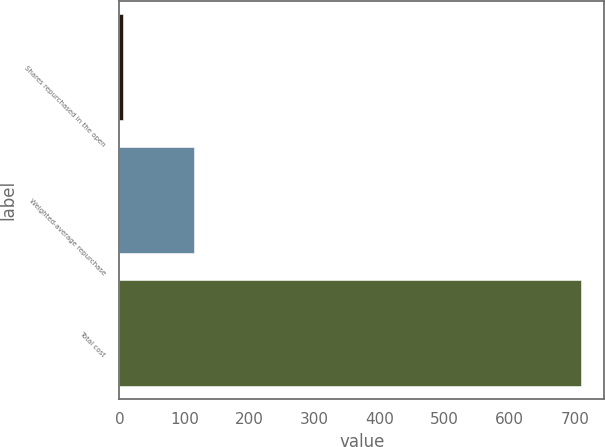Convert chart to OTSL. <chart><loc_0><loc_0><loc_500><loc_500><bar_chart><fcel>Shares repurchased in the open<fcel>Weighted-average repurchase<fcel>Total cost<nl><fcel>6<fcel>114.87<fcel>710<nl></chart> 